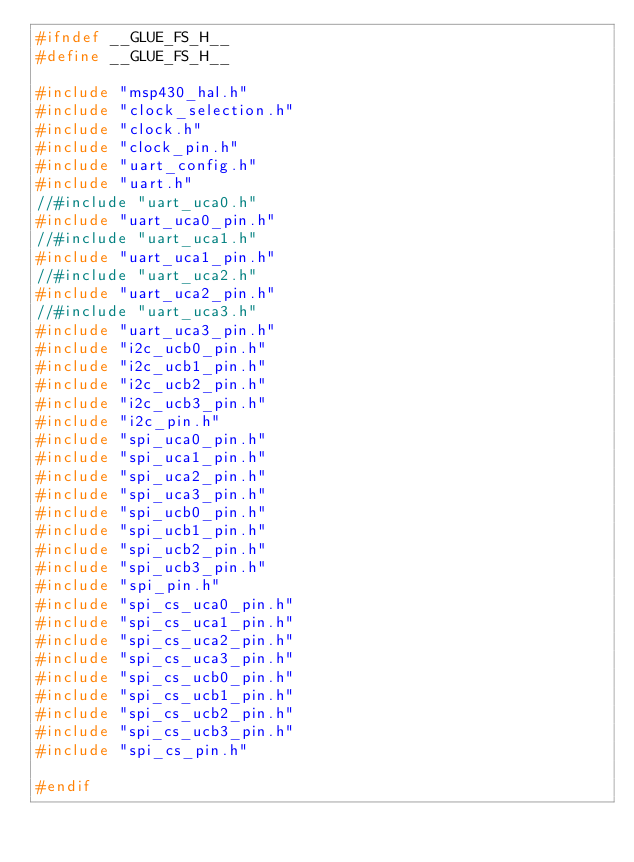<code> <loc_0><loc_0><loc_500><loc_500><_C_>#ifndef __GLUE_FS_H__
#define __GLUE_FS_H__

#include "msp430_hal.h"
#include "clock_selection.h"
#include "clock.h"
#include "clock_pin.h"
#include "uart_config.h"
#include "uart.h"
//#include "uart_uca0.h"
#include "uart_uca0_pin.h"
//#include "uart_uca1.h"
#include "uart_uca1_pin.h"
//#include "uart_uca2.h"
#include "uart_uca2_pin.h"
//#include "uart_uca3.h"
#include "uart_uca3_pin.h"
#include "i2c_ucb0_pin.h"
#include "i2c_ucb1_pin.h"
#include "i2c_ucb2_pin.h"
#include "i2c_ucb3_pin.h"
#include "i2c_pin.h"
#include "spi_uca0_pin.h"
#include "spi_uca1_pin.h"
#include "spi_uca2_pin.h"
#include "spi_uca3_pin.h"
#include "spi_ucb0_pin.h"
#include "spi_ucb1_pin.h"
#include "spi_ucb2_pin.h"
#include "spi_ucb3_pin.h"
#include "spi_pin.h"
#include "spi_cs_uca0_pin.h"
#include "spi_cs_uca1_pin.h"
#include "spi_cs_uca2_pin.h"
#include "spi_cs_uca3_pin.h"
#include "spi_cs_ucb0_pin.h"
#include "spi_cs_ucb1_pin.h"
#include "spi_cs_ucb2_pin.h"
#include "spi_cs_ucb3_pin.h"
#include "spi_cs_pin.h"

#endif
</code> 